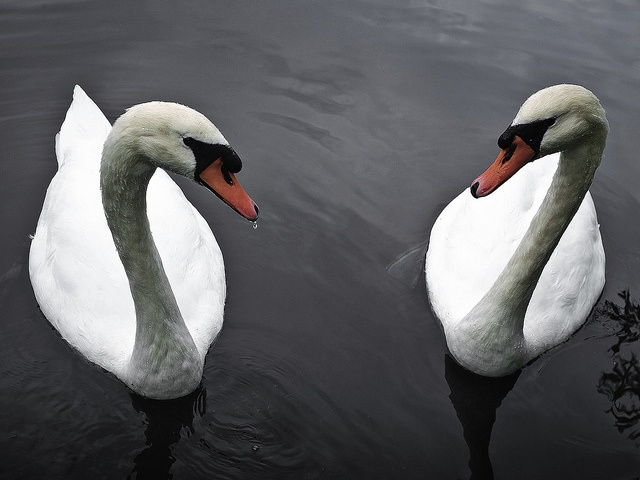Describe the objects in this image and their specific colors. I can see bird in gray, white, black, and darkgray tones and bird in gray, white, darkgray, and black tones in this image. 